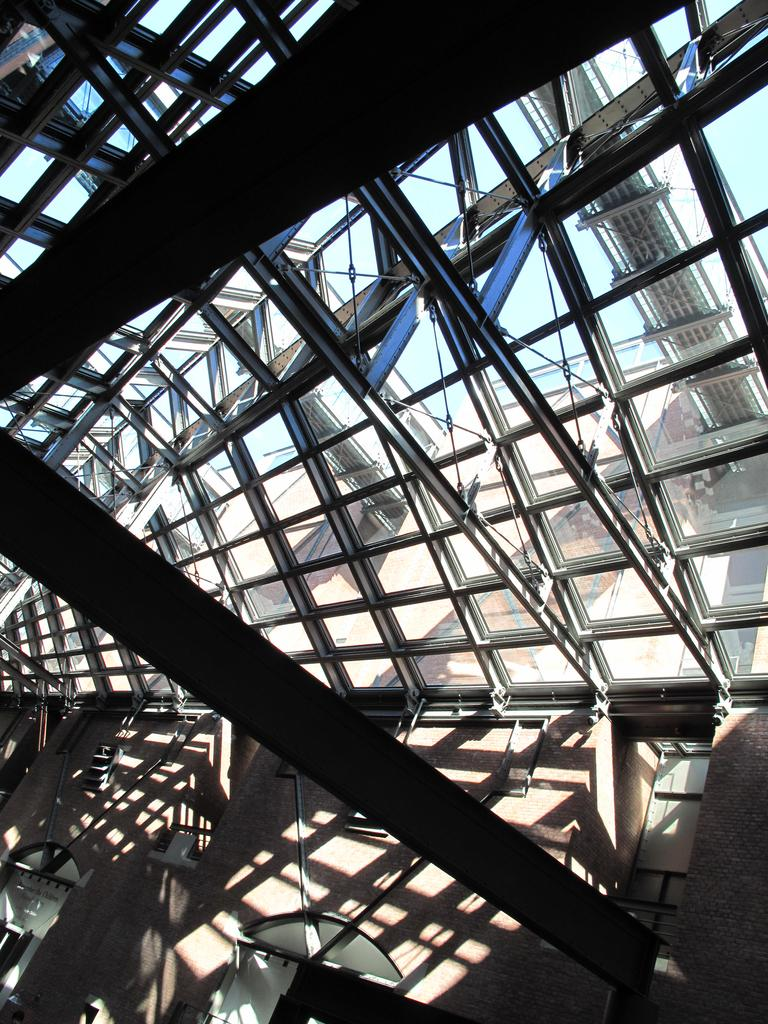What type of roof is present in the image? There is a glass roof in the image. What can be seen through the glass roof? The sky, rods, and objects are visible through the glass roof. What other structures are present in the image? There is a wall in the image. What are the rods used for in the image? The purpose of the rods is not specified in the image. Can you see a trail of geese flying through the sky in the image? There is no trail of geese or any geese visible in the image. What type of beef is being cooked in the image? There is no beef or any cooking activity present in the image. 